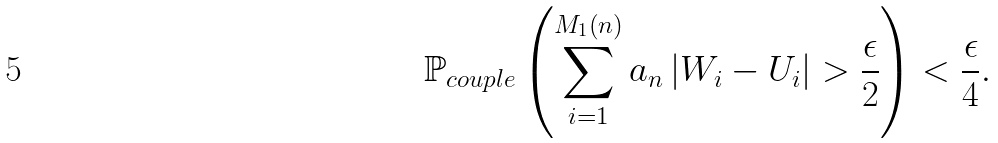<formula> <loc_0><loc_0><loc_500><loc_500>\mathbb { P } _ { c o u p l e } \left ( \sum _ { i = 1 } ^ { M _ { 1 } \left ( n \right ) } a _ { n } \left | W _ { i } - U _ { i } \right | > \frac { \epsilon } { 2 } \right ) < \frac { \epsilon } { 4 } .</formula> 